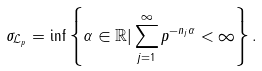Convert formula to latex. <formula><loc_0><loc_0><loc_500><loc_500>\sigma _ { \mathcal { L } _ { p } } = \inf \left \{ \alpha \in \mathbb { R } | \sum _ { j = 1 } ^ { \infty } p ^ { - n _ { j } \alpha } < \infty \right \} .</formula> 